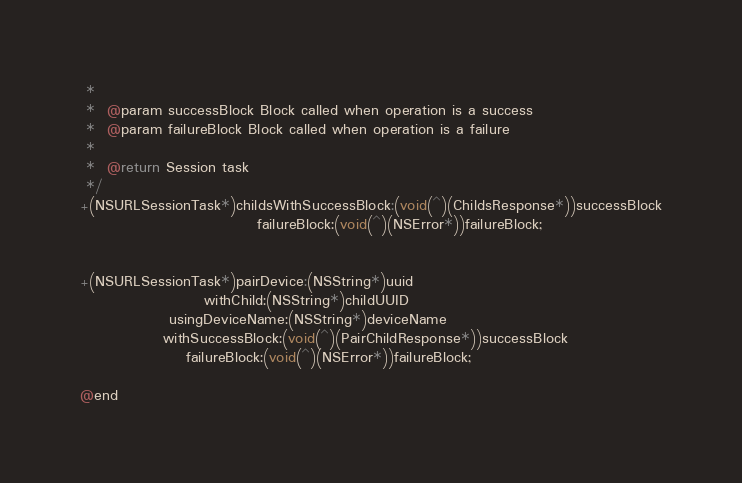<code> <loc_0><loc_0><loc_500><loc_500><_C_> *
 *  @param successBlock Block called when operation is a success
 *  @param failureBlock Block called when operation is a failure
 *
 *  @return Session task
 */
+(NSURLSessionTask*)childsWithSuccessBlock:(void(^)(ChildsResponse*))successBlock
                              failureBlock:(void(^)(NSError*))failureBlock;


+(NSURLSessionTask*)pairDevice:(NSString*)uuid
                     withChild:(NSString*)childUUID
               usingDeviceName:(NSString*)deviceName
              withSuccessBlock:(void(^)(PairChildResponse*))successBlock
                  failureBlock:(void(^)(NSError*))failureBlock;

@end
</code> 